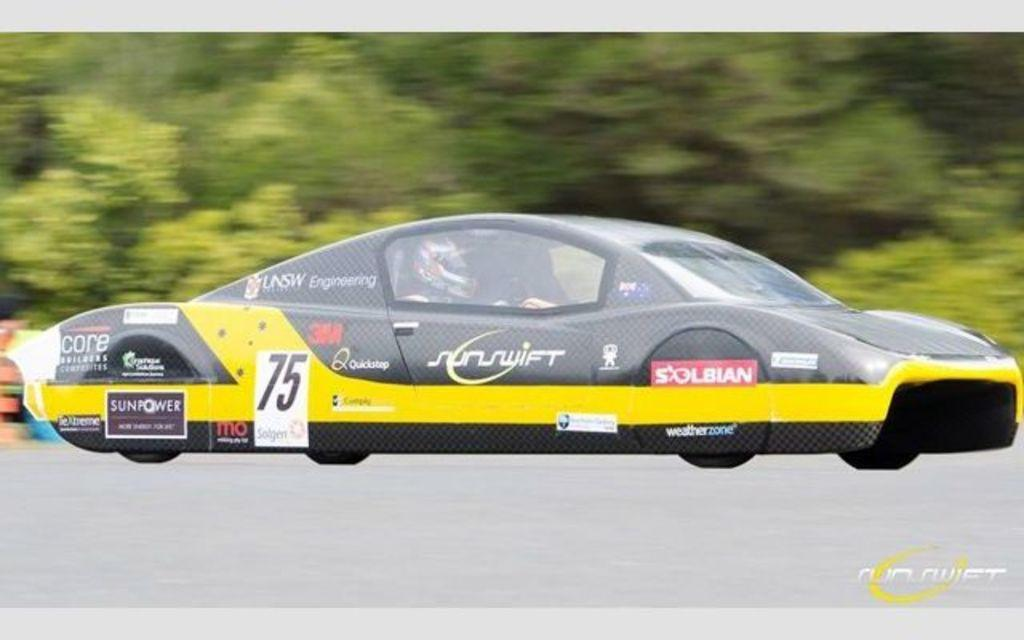What is the person in the image doing? The person is driving in the image. What type of car is the person driving? The person is driving a sports car. Where is the car located? The car is on the road. What can be seen in the background of the image? There are trees in the background of the image. How does the car aid in the person's digestion while driving? The car does not aid in the person's digestion; it is a vehicle for transportation. 